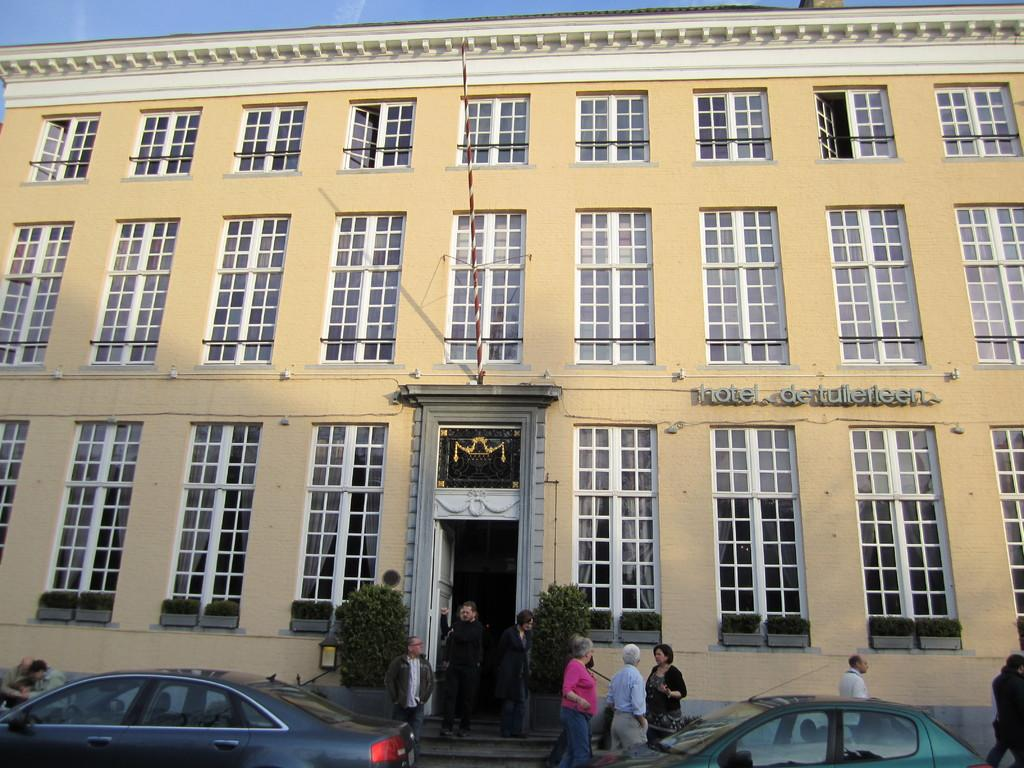Who or what can be seen in the image? There are people in the image. What else is present in the image besides people? There are cars, plants, a pole, windows, text on a wall, and the sky visible in the background. Can you describe the cars in the image? There are cars in the image, but their specific features or models are not mentioned in the facts. What is the purpose of the pole in the image? The purpose of the pole is not mentioned in the facts, so we cannot determine its function. What is written on the wall in the image? The text on the wall is not mentioned in the facts, so we cannot determine its content. What type of machine is being used to fall from the sky in the image? There is no machine or falling object present in the image. How many car engines can be seen in the image? The facts do not mention any car engines, so we cannot determine their number or presence in the image. 